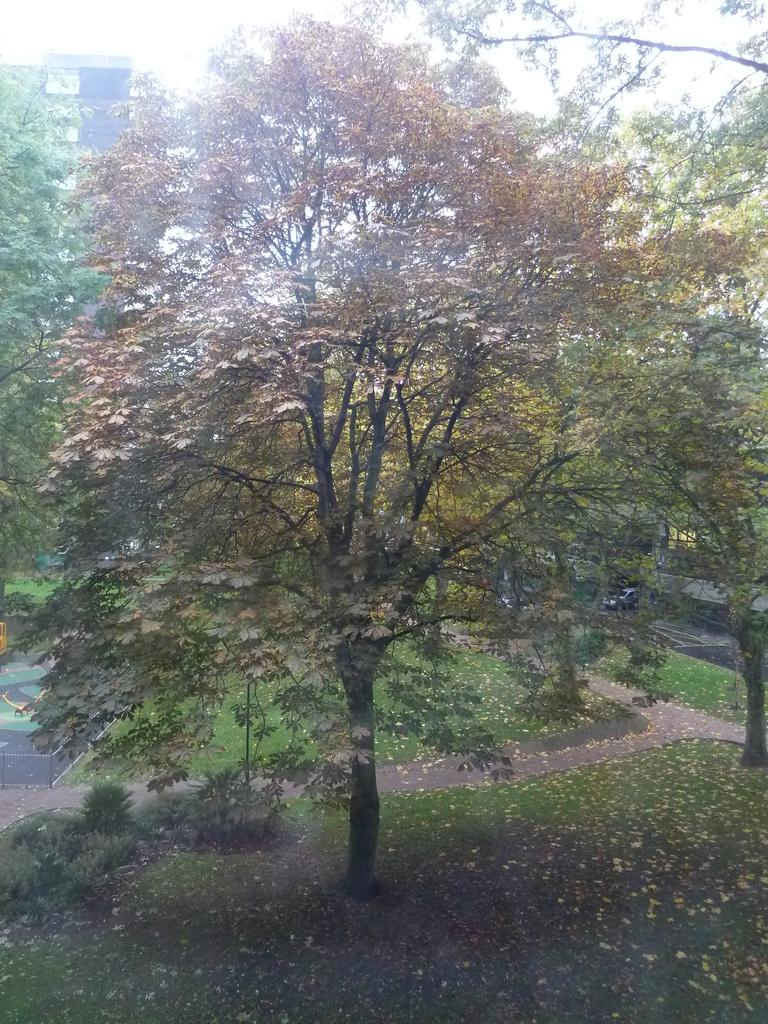What type of vegetation can be seen in the image? There are trees in the image. What mode of transportation is visible in the image? There is a car in the image. What type of ground is present at the bottom of the image? Grass is present at the bottom of the image. What is visible in the background of the image? The sky is visible in the background of the image. Can you tell me how many cups are placed on the grass in the image? There are no cups present in the image; it features trees, a car, grass, and the sky. Is the car stuck in quicksand in the image? There is no quicksand present in the image, and the car is not shown in any precarious situation. 